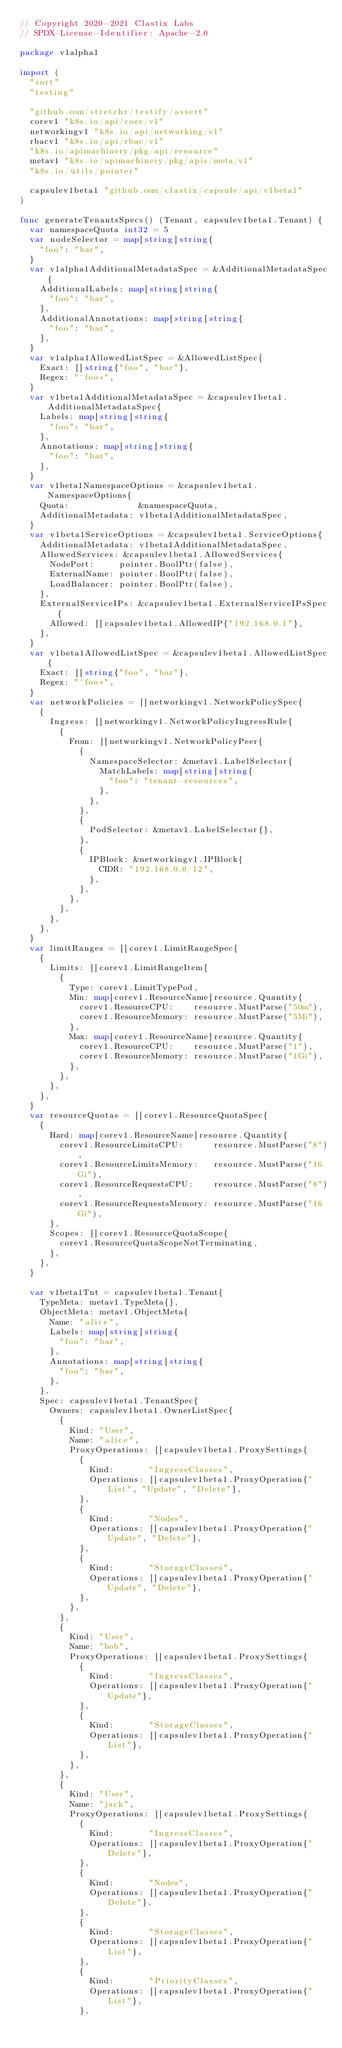Convert code to text. <code><loc_0><loc_0><loc_500><loc_500><_Go_>// Copyright 2020-2021 Clastix Labs
// SPDX-License-Identifier: Apache-2.0

package v1alpha1

import (
	"sort"
	"testing"

	"github.com/stretchr/testify/assert"
	corev1 "k8s.io/api/core/v1"
	networkingv1 "k8s.io/api/networking/v1"
	rbacv1 "k8s.io/api/rbac/v1"
	"k8s.io/apimachinery/pkg/api/resource"
	metav1 "k8s.io/apimachinery/pkg/apis/meta/v1"
	"k8s.io/utils/pointer"

	capsulev1beta1 "github.com/clastix/capsule/api/v1beta1"
)

func generateTenantsSpecs() (Tenant, capsulev1beta1.Tenant) {
	var namespaceQuota int32 = 5
	var nodeSelector = map[string]string{
		"foo": "bar",
	}
	var v1alpha1AdditionalMetadataSpec = &AdditionalMetadataSpec{
		AdditionalLabels: map[string]string{
			"foo": "bar",
		},
		AdditionalAnnotations: map[string]string{
			"foo": "bar",
		},
	}
	var v1alpha1AllowedListSpec = &AllowedListSpec{
		Exact: []string{"foo", "bar"},
		Regex: "^foo*",
	}
	var v1beta1AdditionalMetadataSpec = &capsulev1beta1.AdditionalMetadataSpec{
		Labels: map[string]string{
			"foo": "bar",
		},
		Annotations: map[string]string{
			"foo": "bar",
		},
	}
	var v1beta1NamespaceOptions = &capsulev1beta1.NamespaceOptions{
		Quota:              &namespaceQuota,
		AdditionalMetadata: v1beta1AdditionalMetadataSpec,
	}
	var v1beta1ServiceOptions = &capsulev1beta1.ServiceOptions{
		AdditionalMetadata: v1beta1AdditionalMetadataSpec,
		AllowedServices: &capsulev1beta1.AllowedServices{
			NodePort:     pointer.BoolPtr(false),
			ExternalName: pointer.BoolPtr(false),
			LoadBalancer: pointer.BoolPtr(false),
		},
		ExternalServiceIPs: &capsulev1beta1.ExternalServiceIPsSpec{
			Allowed: []capsulev1beta1.AllowedIP{"192.168.0.1"},
		},
	}
	var v1beta1AllowedListSpec = &capsulev1beta1.AllowedListSpec{
		Exact: []string{"foo", "bar"},
		Regex: "^foo*",
	}
	var networkPolicies = []networkingv1.NetworkPolicySpec{
		{
			Ingress: []networkingv1.NetworkPolicyIngressRule{
				{
					From: []networkingv1.NetworkPolicyPeer{
						{
							NamespaceSelector: &metav1.LabelSelector{
								MatchLabels: map[string]string{
									"foo": "tenant-resources",
								},
							},
						},
						{
							PodSelector: &metav1.LabelSelector{},
						},
						{
							IPBlock: &networkingv1.IPBlock{
								CIDR: "192.168.0.0/12",
							},
						},
					},
				},
			},
		},
	}
	var limitRanges = []corev1.LimitRangeSpec{
		{
			Limits: []corev1.LimitRangeItem{
				{
					Type: corev1.LimitTypePod,
					Min: map[corev1.ResourceName]resource.Quantity{
						corev1.ResourceCPU:    resource.MustParse("50m"),
						corev1.ResourceMemory: resource.MustParse("5Mi"),
					},
					Max: map[corev1.ResourceName]resource.Quantity{
						corev1.ResourceCPU:    resource.MustParse("1"),
						corev1.ResourceMemory: resource.MustParse("1Gi"),
					},
				},
			},
		},
	}
	var resourceQuotas = []corev1.ResourceQuotaSpec{
		{
			Hard: map[corev1.ResourceName]resource.Quantity{
				corev1.ResourceLimitsCPU:      resource.MustParse("8"),
				corev1.ResourceLimitsMemory:   resource.MustParse("16Gi"),
				corev1.ResourceRequestsCPU:    resource.MustParse("8"),
				corev1.ResourceRequestsMemory: resource.MustParse("16Gi"),
			},
			Scopes: []corev1.ResourceQuotaScope{
				corev1.ResourceQuotaScopeNotTerminating,
			},
		},
	}

	var v1beta1Tnt = capsulev1beta1.Tenant{
		TypeMeta: metav1.TypeMeta{},
		ObjectMeta: metav1.ObjectMeta{
			Name: "alice",
			Labels: map[string]string{
				"foo": "bar",
			},
			Annotations: map[string]string{
				"foo": "bar",
			},
		},
		Spec: capsulev1beta1.TenantSpec{
			Owners: capsulev1beta1.OwnerListSpec{
				{
					Kind: "User",
					Name: "alice",
					ProxyOperations: []capsulev1beta1.ProxySettings{
						{
							Kind:       "IngressClasses",
							Operations: []capsulev1beta1.ProxyOperation{"List", "Update", "Delete"},
						},
						{
							Kind:       "Nodes",
							Operations: []capsulev1beta1.ProxyOperation{"Update", "Delete"},
						},
						{
							Kind:       "StorageClasses",
							Operations: []capsulev1beta1.ProxyOperation{"Update", "Delete"},
						},
					},
				},
				{
					Kind: "User",
					Name: "bob",
					ProxyOperations: []capsulev1beta1.ProxySettings{
						{
							Kind:       "IngressClasses",
							Operations: []capsulev1beta1.ProxyOperation{"Update"},
						},
						{
							Kind:       "StorageClasses",
							Operations: []capsulev1beta1.ProxyOperation{"List"},
						},
					},
				},
				{
					Kind: "User",
					Name: "jack",
					ProxyOperations: []capsulev1beta1.ProxySettings{
						{
							Kind:       "IngressClasses",
							Operations: []capsulev1beta1.ProxyOperation{"Delete"},
						},
						{
							Kind:       "Nodes",
							Operations: []capsulev1beta1.ProxyOperation{"Delete"},
						},
						{
							Kind:       "StorageClasses",
							Operations: []capsulev1beta1.ProxyOperation{"List"},
						},
						{
							Kind:       "PriorityClasses",
							Operations: []capsulev1beta1.ProxyOperation{"List"},
						},</code> 